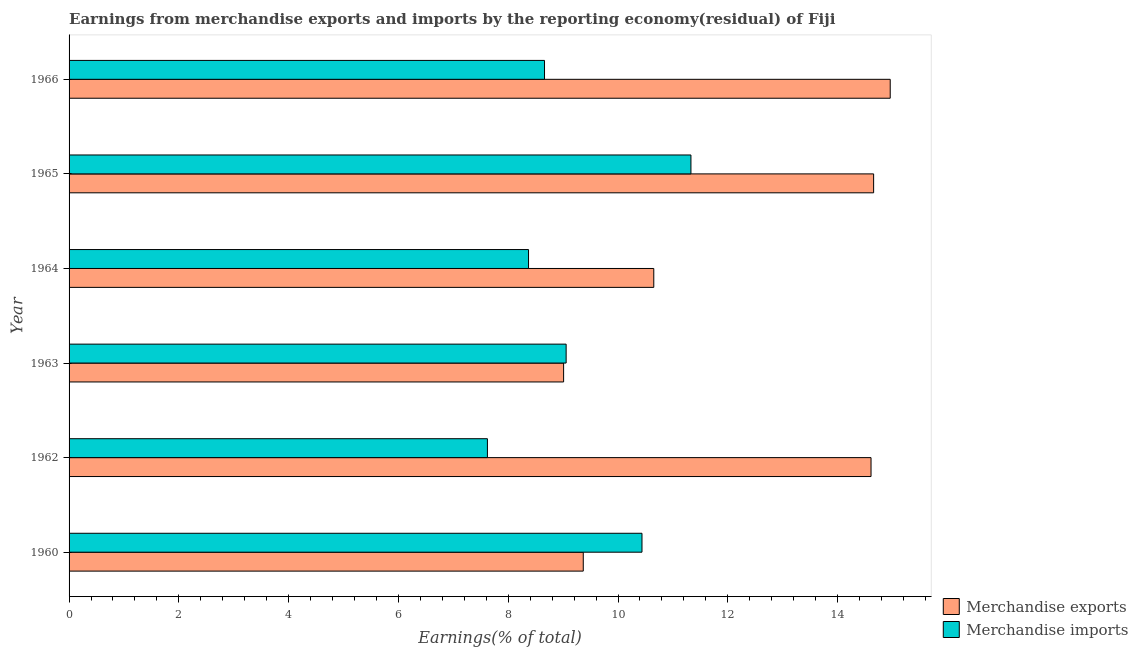Are the number of bars per tick equal to the number of legend labels?
Give a very brief answer. Yes. Are the number of bars on each tick of the Y-axis equal?
Ensure brevity in your answer.  Yes. How many bars are there on the 6th tick from the top?
Offer a terse response. 2. What is the label of the 6th group of bars from the top?
Keep it short and to the point. 1960. What is the earnings from merchandise imports in 1965?
Make the answer very short. 11.33. Across all years, what is the maximum earnings from merchandise exports?
Your answer should be compact. 14.96. Across all years, what is the minimum earnings from merchandise exports?
Make the answer very short. 9.01. In which year was the earnings from merchandise exports maximum?
Give a very brief answer. 1966. What is the total earnings from merchandise exports in the graph?
Ensure brevity in your answer.  73.25. What is the difference between the earnings from merchandise exports in 1962 and that in 1965?
Provide a succinct answer. -0.05. What is the difference between the earnings from merchandise exports in 1962 and the earnings from merchandise imports in 1965?
Provide a succinct answer. 3.28. What is the average earnings from merchandise exports per year?
Ensure brevity in your answer.  12.21. In the year 1965, what is the difference between the earnings from merchandise exports and earnings from merchandise imports?
Offer a very short reply. 3.33. What is the ratio of the earnings from merchandise imports in 1962 to that in 1966?
Make the answer very short. 0.88. Is the difference between the earnings from merchandise imports in 1963 and 1964 greater than the difference between the earnings from merchandise exports in 1963 and 1964?
Provide a short and direct response. Yes. What is the difference between the highest and the second highest earnings from merchandise exports?
Ensure brevity in your answer.  0.3. What is the difference between the highest and the lowest earnings from merchandise imports?
Offer a terse response. 3.71. Is the sum of the earnings from merchandise imports in 1964 and 1965 greater than the maximum earnings from merchandise exports across all years?
Offer a terse response. Yes. What does the 2nd bar from the top in 1960 represents?
Keep it short and to the point. Merchandise exports. What does the 1st bar from the bottom in 1966 represents?
Your answer should be very brief. Merchandise exports. How many bars are there?
Your answer should be very brief. 12. Are all the bars in the graph horizontal?
Your answer should be very brief. Yes. What is the difference between two consecutive major ticks on the X-axis?
Provide a short and direct response. 2. Are the values on the major ticks of X-axis written in scientific E-notation?
Your response must be concise. No. Does the graph contain any zero values?
Provide a succinct answer. No. Does the graph contain grids?
Your response must be concise. No. How are the legend labels stacked?
Offer a very short reply. Vertical. What is the title of the graph?
Your answer should be very brief. Earnings from merchandise exports and imports by the reporting economy(residual) of Fiji. Does "All education staff compensation" appear as one of the legend labels in the graph?
Your answer should be very brief. No. What is the label or title of the X-axis?
Offer a terse response. Earnings(% of total). What is the Earnings(% of total) in Merchandise exports in 1960?
Give a very brief answer. 9.37. What is the Earnings(% of total) of Merchandise imports in 1960?
Give a very brief answer. 10.44. What is the Earnings(% of total) of Merchandise exports in 1962?
Provide a succinct answer. 14.61. What is the Earnings(% of total) of Merchandise imports in 1962?
Provide a succinct answer. 7.62. What is the Earnings(% of total) of Merchandise exports in 1963?
Offer a very short reply. 9.01. What is the Earnings(% of total) of Merchandise imports in 1963?
Ensure brevity in your answer.  9.06. What is the Earnings(% of total) of Merchandise exports in 1964?
Make the answer very short. 10.65. What is the Earnings(% of total) of Merchandise imports in 1964?
Give a very brief answer. 8.37. What is the Earnings(% of total) in Merchandise exports in 1965?
Ensure brevity in your answer.  14.66. What is the Earnings(% of total) of Merchandise imports in 1965?
Offer a very short reply. 11.33. What is the Earnings(% of total) of Merchandise exports in 1966?
Give a very brief answer. 14.96. What is the Earnings(% of total) of Merchandise imports in 1966?
Provide a succinct answer. 8.66. Across all years, what is the maximum Earnings(% of total) of Merchandise exports?
Offer a very short reply. 14.96. Across all years, what is the maximum Earnings(% of total) of Merchandise imports?
Keep it short and to the point. 11.33. Across all years, what is the minimum Earnings(% of total) of Merchandise exports?
Provide a short and direct response. 9.01. Across all years, what is the minimum Earnings(% of total) in Merchandise imports?
Offer a terse response. 7.62. What is the total Earnings(% of total) of Merchandise exports in the graph?
Give a very brief answer. 73.25. What is the total Earnings(% of total) of Merchandise imports in the graph?
Keep it short and to the point. 55.47. What is the difference between the Earnings(% of total) in Merchandise exports in 1960 and that in 1962?
Offer a very short reply. -5.24. What is the difference between the Earnings(% of total) of Merchandise imports in 1960 and that in 1962?
Ensure brevity in your answer.  2.82. What is the difference between the Earnings(% of total) in Merchandise exports in 1960 and that in 1963?
Provide a short and direct response. 0.36. What is the difference between the Earnings(% of total) of Merchandise imports in 1960 and that in 1963?
Offer a very short reply. 1.38. What is the difference between the Earnings(% of total) of Merchandise exports in 1960 and that in 1964?
Your answer should be very brief. -1.28. What is the difference between the Earnings(% of total) in Merchandise imports in 1960 and that in 1964?
Your answer should be compact. 2.07. What is the difference between the Earnings(% of total) in Merchandise exports in 1960 and that in 1965?
Make the answer very short. -5.29. What is the difference between the Earnings(% of total) in Merchandise imports in 1960 and that in 1965?
Ensure brevity in your answer.  -0.89. What is the difference between the Earnings(% of total) of Merchandise exports in 1960 and that in 1966?
Your answer should be very brief. -5.59. What is the difference between the Earnings(% of total) in Merchandise imports in 1960 and that in 1966?
Your response must be concise. 1.78. What is the difference between the Earnings(% of total) of Merchandise exports in 1962 and that in 1963?
Your response must be concise. 5.6. What is the difference between the Earnings(% of total) in Merchandise imports in 1962 and that in 1963?
Provide a short and direct response. -1.43. What is the difference between the Earnings(% of total) of Merchandise exports in 1962 and that in 1964?
Ensure brevity in your answer.  3.96. What is the difference between the Earnings(% of total) in Merchandise imports in 1962 and that in 1964?
Your response must be concise. -0.75. What is the difference between the Earnings(% of total) in Merchandise exports in 1962 and that in 1965?
Your answer should be very brief. -0.05. What is the difference between the Earnings(% of total) of Merchandise imports in 1962 and that in 1965?
Provide a short and direct response. -3.71. What is the difference between the Earnings(% of total) of Merchandise exports in 1962 and that in 1966?
Keep it short and to the point. -0.35. What is the difference between the Earnings(% of total) in Merchandise imports in 1962 and that in 1966?
Offer a terse response. -1.04. What is the difference between the Earnings(% of total) in Merchandise exports in 1963 and that in 1964?
Ensure brevity in your answer.  -1.64. What is the difference between the Earnings(% of total) in Merchandise imports in 1963 and that in 1964?
Keep it short and to the point. 0.69. What is the difference between the Earnings(% of total) in Merchandise exports in 1963 and that in 1965?
Make the answer very short. -5.65. What is the difference between the Earnings(% of total) in Merchandise imports in 1963 and that in 1965?
Give a very brief answer. -2.27. What is the difference between the Earnings(% of total) in Merchandise exports in 1963 and that in 1966?
Provide a short and direct response. -5.95. What is the difference between the Earnings(% of total) of Merchandise imports in 1963 and that in 1966?
Ensure brevity in your answer.  0.39. What is the difference between the Earnings(% of total) in Merchandise exports in 1964 and that in 1965?
Ensure brevity in your answer.  -4. What is the difference between the Earnings(% of total) in Merchandise imports in 1964 and that in 1965?
Give a very brief answer. -2.96. What is the difference between the Earnings(% of total) in Merchandise exports in 1964 and that in 1966?
Your answer should be compact. -4.31. What is the difference between the Earnings(% of total) in Merchandise imports in 1964 and that in 1966?
Give a very brief answer. -0.29. What is the difference between the Earnings(% of total) in Merchandise exports in 1965 and that in 1966?
Your answer should be compact. -0.3. What is the difference between the Earnings(% of total) of Merchandise imports in 1965 and that in 1966?
Offer a terse response. 2.67. What is the difference between the Earnings(% of total) of Merchandise exports in 1960 and the Earnings(% of total) of Merchandise imports in 1962?
Your answer should be very brief. 1.75. What is the difference between the Earnings(% of total) in Merchandise exports in 1960 and the Earnings(% of total) in Merchandise imports in 1963?
Your answer should be very brief. 0.31. What is the difference between the Earnings(% of total) in Merchandise exports in 1960 and the Earnings(% of total) in Merchandise imports in 1965?
Provide a short and direct response. -1.96. What is the difference between the Earnings(% of total) in Merchandise exports in 1960 and the Earnings(% of total) in Merchandise imports in 1966?
Give a very brief answer. 0.71. What is the difference between the Earnings(% of total) in Merchandise exports in 1962 and the Earnings(% of total) in Merchandise imports in 1963?
Your answer should be compact. 5.55. What is the difference between the Earnings(% of total) of Merchandise exports in 1962 and the Earnings(% of total) of Merchandise imports in 1964?
Keep it short and to the point. 6.24. What is the difference between the Earnings(% of total) of Merchandise exports in 1962 and the Earnings(% of total) of Merchandise imports in 1965?
Ensure brevity in your answer.  3.28. What is the difference between the Earnings(% of total) of Merchandise exports in 1962 and the Earnings(% of total) of Merchandise imports in 1966?
Your answer should be very brief. 5.95. What is the difference between the Earnings(% of total) of Merchandise exports in 1963 and the Earnings(% of total) of Merchandise imports in 1964?
Provide a succinct answer. 0.64. What is the difference between the Earnings(% of total) in Merchandise exports in 1963 and the Earnings(% of total) in Merchandise imports in 1965?
Offer a terse response. -2.32. What is the difference between the Earnings(% of total) in Merchandise exports in 1963 and the Earnings(% of total) in Merchandise imports in 1966?
Offer a very short reply. 0.35. What is the difference between the Earnings(% of total) in Merchandise exports in 1964 and the Earnings(% of total) in Merchandise imports in 1965?
Your answer should be compact. -0.68. What is the difference between the Earnings(% of total) in Merchandise exports in 1964 and the Earnings(% of total) in Merchandise imports in 1966?
Your response must be concise. 1.99. What is the difference between the Earnings(% of total) of Merchandise exports in 1965 and the Earnings(% of total) of Merchandise imports in 1966?
Your response must be concise. 6. What is the average Earnings(% of total) of Merchandise exports per year?
Your response must be concise. 12.21. What is the average Earnings(% of total) in Merchandise imports per year?
Keep it short and to the point. 9.25. In the year 1960, what is the difference between the Earnings(% of total) in Merchandise exports and Earnings(% of total) in Merchandise imports?
Provide a short and direct response. -1.07. In the year 1962, what is the difference between the Earnings(% of total) in Merchandise exports and Earnings(% of total) in Merchandise imports?
Offer a very short reply. 6.99. In the year 1963, what is the difference between the Earnings(% of total) of Merchandise exports and Earnings(% of total) of Merchandise imports?
Provide a short and direct response. -0.05. In the year 1964, what is the difference between the Earnings(% of total) of Merchandise exports and Earnings(% of total) of Merchandise imports?
Your answer should be compact. 2.28. In the year 1965, what is the difference between the Earnings(% of total) in Merchandise exports and Earnings(% of total) in Merchandise imports?
Your response must be concise. 3.33. In the year 1966, what is the difference between the Earnings(% of total) of Merchandise exports and Earnings(% of total) of Merchandise imports?
Your answer should be compact. 6.3. What is the ratio of the Earnings(% of total) of Merchandise exports in 1960 to that in 1962?
Offer a very short reply. 0.64. What is the ratio of the Earnings(% of total) of Merchandise imports in 1960 to that in 1962?
Keep it short and to the point. 1.37. What is the ratio of the Earnings(% of total) of Merchandise exports in 1960 to that in 1963?
Offer a terse response. 1.04. What is the ratio of the Earnings(% of total) of Merchandise imports in 1960 to that in 1963?
Your answer should be very brief. 1.15. What is the ratio of the Earnings(% of total) of Merchandise exports in 1960 to that in 1964?
Offer a terse response. 0.88. What is the ratio of the Earnings(% of total) in Merchandise imports in 1960 to that in 1964?
Offer a terse response. 1.25. What is the ratio of the Earnings(% of total) in Merchandise exports in 1960 to that in 1965?
Provide a short and direct response. 0.64. What is the ratio of the Earnings(% of total) of Merchandise imports in 1960 to that in 1965?
Your answer should be compact. 0.92. What is the ratio of the Earnings(% of total) of Merchandise exports in 1960 to that in 1966?
Offer a very short reply. 0.63. What is the ratio of the Earnings(% of total) in Merchandise imports in 1960 to that in 1966?
Keep it short and to the point. 1.21. What is the ratio of the Earnings(% of total) of Merchandise exports in 1962 to that in 1963?
Make the answer very short. 1.62. What is the ratio of the Earnings(% of total) in Merchandise imports in 1962 to that in 1963?
Your response must be concise. 0.84. What is the ratio of the Earnings(% of total) of Merchandise exports in 1962 to that in 1964?
Give a very brief answer. 1.37. What is the ratio of the Earnings(% of total) in Merchandise imports in 1962 to that in 1964?
Provide a short and direct response. 0.91. What is the ratio of the Earnings(% of total) in Merchandise imports in 1962 to that in 1965?
Offer a terse response. 0.67. What is the ratio of the Earnings(% of total) in Merchandise exports in 1962 to that in 1966?
Make the answer very short. 0.98. What is the ratio of the Earnings(% of total) in Merchandise imports in 1962 to that in 1966?
Your response must be concise. 0.88. What is the ratio of the Earnings(% of total) of Merchandise exports in 1963 to that in 1964?
Provide a succinct answer. 0.85. What is the ratio of the Earnings(% of total) of Merchandise imports in 1963 to that in 1964?
Provide a short and direct response. 1.08. What is the ratio of the Earnings(% of total) in Merchandise exports in 1963 to that in 1965?
Offer a terse response. 0.61. What is the ratio of the Earnings(% of total) of Merchandise imports in 1963 to that in 1965?
Offer a very short reply. 0.8. What is the ratio of the Earnings(% of total) of Merchandise exports in 1963 to that in 1966?
Offer a very short reply. 0.6. What is the ratio of the Earnings(% of total) in Merchandise imports in 1963 to that in 1966?
Provide a short and direct response. 1.05. What is the ratio of the Earnings(% of total) of Merchandise exports in 1964 to that in 1965?
Provide a short and direct response. 0.73. What is the ratio of the Earnings(% of total) in Merchandise imports in 1964 to that in 1965?
Offer a very short reply. 0.74. What is the ratio of the Earnings(% of total) of Merchandise exports in 1964 to that in 1966?
Provide a succinct answer. 0.71. What is the ratio of the Earnings(% of total) of Merchandise imports in 1964 to that in 1966?
Make the answer very short. 0.97. What is the ratio of the Earnings(% of total) in Merchandise exports in 1965 to that in 1966?
Ensure brevity in your answer.  0.98. What is the ratio of the Earnings(% of total) in Merchandise imports in 1965 to that in 1966?
Keep it short and to the point. 1.31. What is the difference between the highest and the second highest Earnings(% of total) in Merchandise exports?
Your answer should be compact. 0.3. What is the difference between the highest and the second highest Earnings(% of total) in Merchandise imports?
Your response must be concise. 0.89. What is the difference between the highest and the lowest Earnings(% of total) in Merchandise exports?
Your answer should be compact. 5.95. What is the difference between the highest and the lowest Earnings(% of total) in Merchandise imports?
Give a very brief answer. 3.71. 